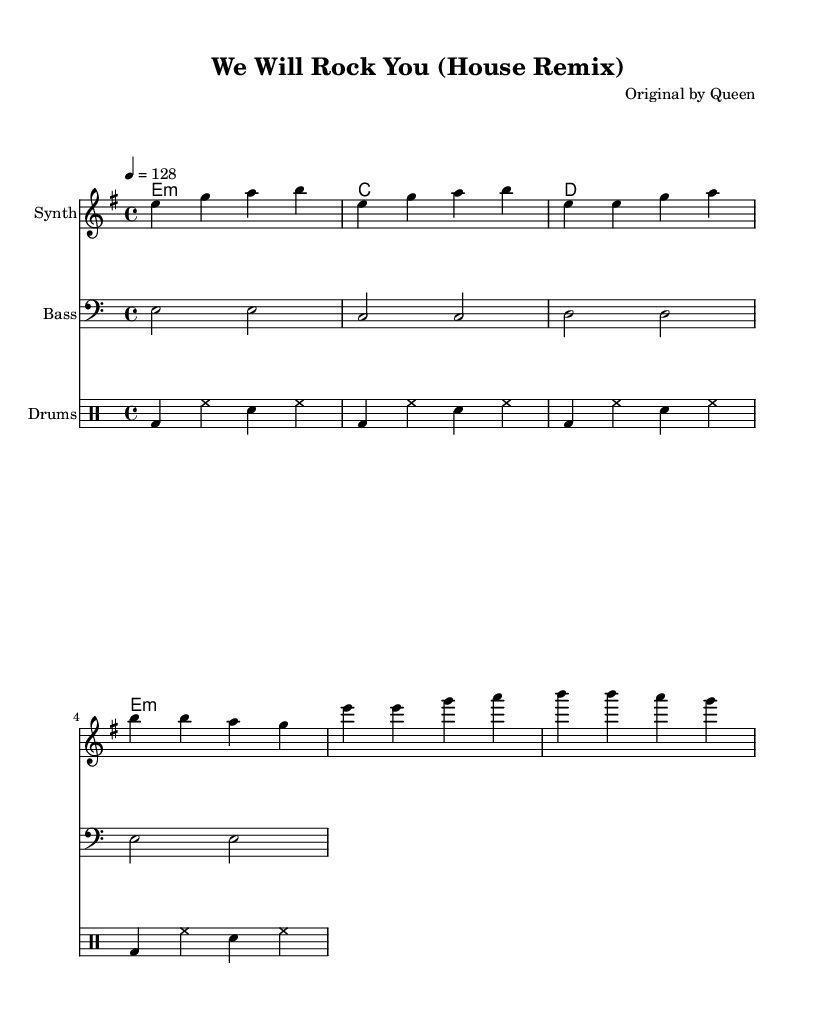What is the key signature of this music? The key signature indicated is E minor, which has one sharp. You can identify the key signature from the beginning of the staff where it is shown.
Answer: E minor What is the time signature of this music? The time signature shown is 4/4, which can be seen at the beginning of the score. This means there are four beats in each measure.
Answer: 4/4 What is the tempo marking for this piece? The tempo is marked as 128 beats per minute, indicated at the beginning of the score where the tempo is set.
Answer: 128 How many measures are in the verse section? The verse section consists of 4 measures, which can be counted visually in the melody part under the verse label, identifying each measure by its vertical lines.
Answer: 4 What instrument plays the melody? The melody is assigned to the "Synth" instrument, as indicated in the staff under the "instrumentName" label.
Answer: Synth How many beats are in the drum pattern? The drum pattern has 16 beats, calculated from the repeat indication of 4 times through a 4-beat pattern (4 beats x 4 repeats = 16 beats).
Answer: 16 What type of chords are used in the harmonies? The chords in the harmonies are minor and major, with the appearing chords being E minor, C major, D major, and E minor again. These are typically seen in the chord mode section.
Answer: Minor and major 